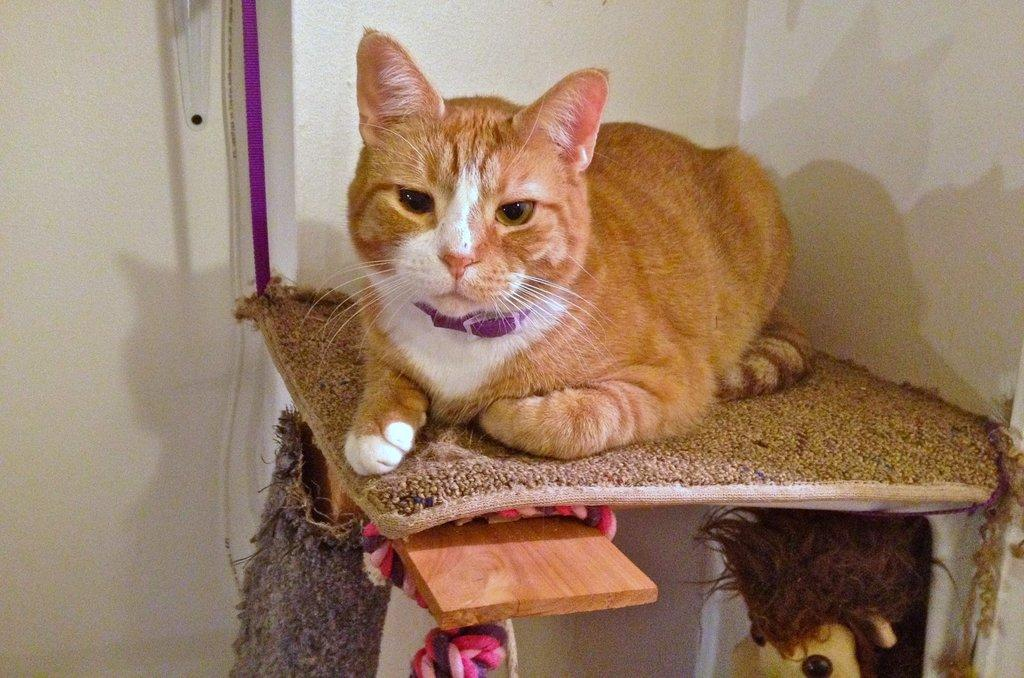What animal is sitting on the table in the image? There is a cat sitting on a table in the image. What is on the table that the cat is sitting on? The table appears to have a mat on it. What can be seen in the background of the image? There is a wall visible in the image. What is hanging from the wire in the image? A wire and an object hanging from it are present in the image. What type of object is visible at the bottom of the image? There is a toy visible at the bottom of the image. What type of flowers are arranged on the table in the image? There are no flowers present in the image; it features a cat sitting on a table with a mat. What type of fruit is hanging from the wire in the image? There is no fruit hanging from the wire in the image; it features an object hanging from the wire. 